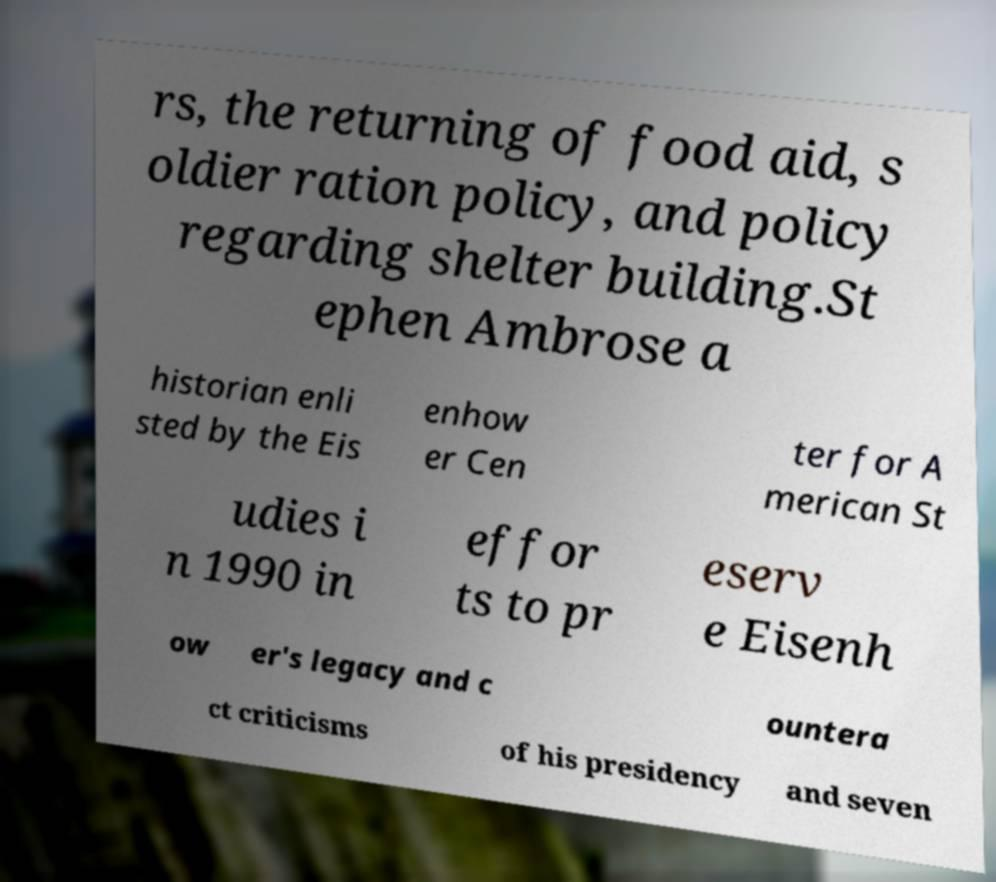There's text embedded in this image that I need extracted. Can you transcribe it verbatim? rs, the returning of food aid, s oldier ration policy, and policy regarding shelter building.St ephen Ambrose a historian enli sted by the Eis enhow er Cen ter for A merican St udies i n 1990 in effor ts to pr eserv e Eisenh ow er's legacy and c ountera ct criticisms of his presidency and seven 